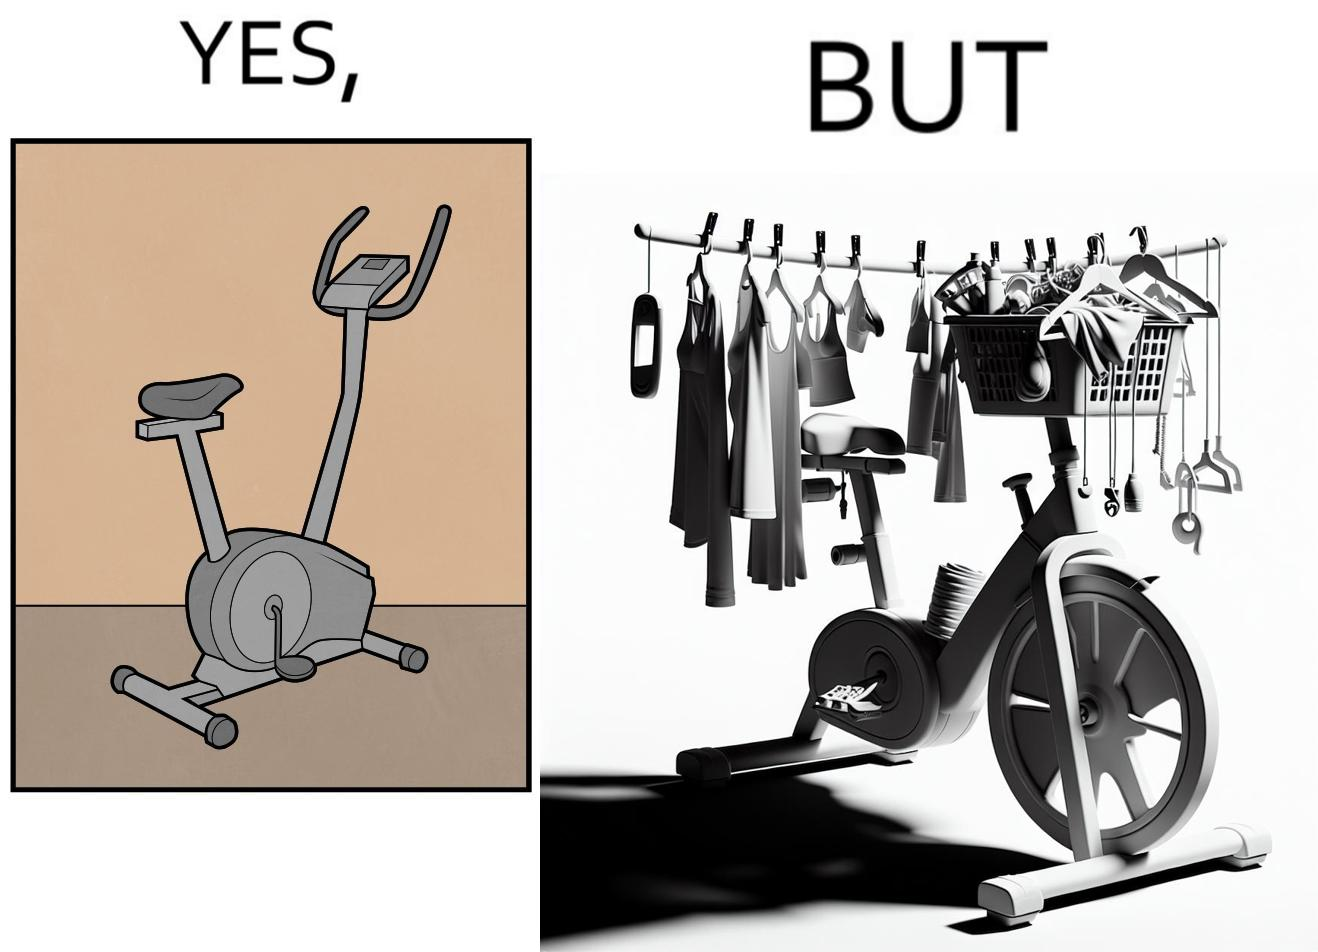Why is this image considered satirical? The images are funny since they show an exercise bike has been bought but is not being used for its purpose, that is, exercising. It is rather being used to hang clothes, bags and other items 